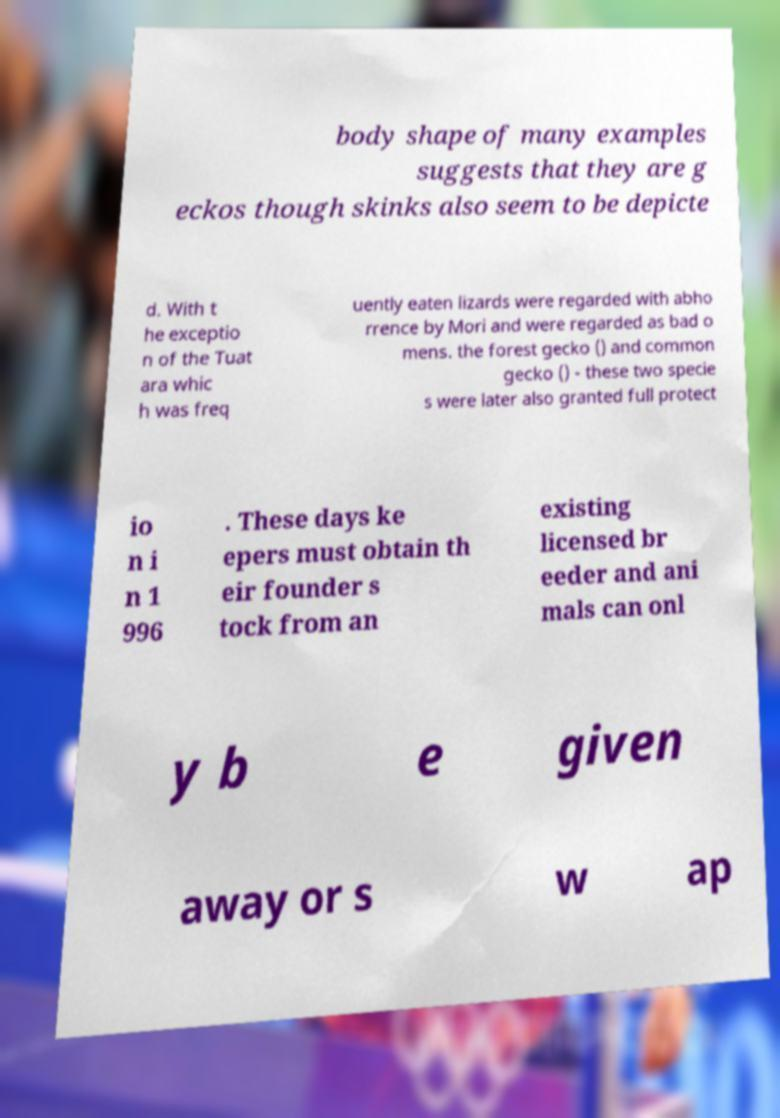Please read and relay the text visible in this image. What does it say? body shape of many examples suggests that they are g eckos though skinks also seem to be depicte d. With t he exceptio n of the Tuat ara whic h was freq uently eaten lizards were regarded with abho rrence by Mori and were regarded as bad o mens. the forest gecko () and common gecko () - these two specie s were later also granted full protect io n i n 1 996 . These days ke epers must obtain th eir founder s tock from an existing licensed br eeder and ani mals can onl y b e given away or s w ap 